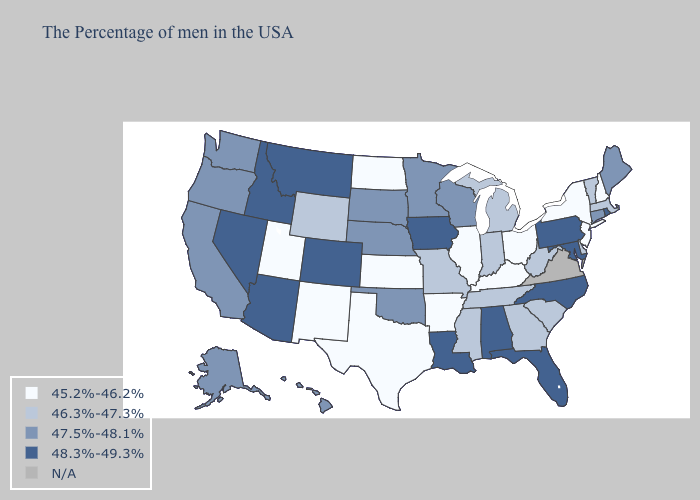Is the legend a continuous bar?
Keep it brief. No. Name the states that have a value in the range 48.3%-49.3%?
Short answer required. Rhode Island, Maryland, Pennsylvania, North Carolina, Florida, Alabama, Louisiana, Iowa, Colorado, Montana, Arizona, Idaho, Nevada. What is the value of Wisconsin?
Answer briefly. 47.5%-48.1%. Does Idaho have the highest value in the West?
Quick response, please. Yes. Name the states that have a value in the range N/A?
Concise answer only. Virginia. Does Georgia have the lowest value in the South?
Short answer required. No. Among the states that border Ohio , which have the lowest value?
Give a very brief answer. Kentucky. What is the value of Nebraska?
Quick response, please. 47.5%-48.1%. What is the value of California?
Be succinct. 47.5%-48.1%. Name the states that have a value in the range 46.3%-47.3%?
Answer briefly. Massachusetts, Vermont, Delaware, South Carolina, West Virginia, Georgia, Michigan, Indiana, Tennessee, Mississippi, Missouri, Wyoming. Which states have the highest value in the USA?
Keep it brief. Rhode Island, Maryland, Pennsylvania, North Carolina, Florida, Alabama, Louisiana, Iowa, Colorado, Montana, Arizona, Idaho, Nevada. Name the states that have a value in the range 47.5%-48.1%?
Answer briefly. Maine, Connecticut, Wisconsin, Minnesota, Nebraska, Oklahoma, South Dakota, California, Washington, Oregon, Alaska, Hawaii. Which states have the lowest value in the USA?
Be succinct. New Hampshire, New York, New Jersey, Ohio, Kentucky, Illinois, Arkansas, Kansas, Texas, North Dakota, New Mexico, Utah. What is the lowest value in the Northeast?
Answer briefly. 45.2%-46.2%. 